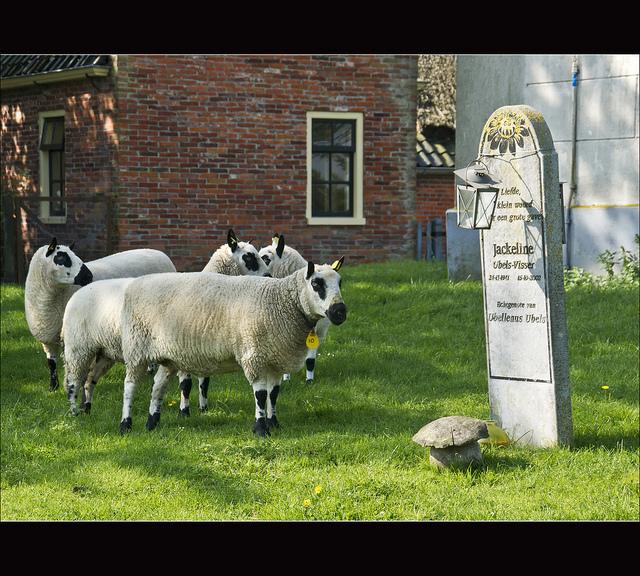How many animals are there?
Be succinct. 4. What kind of animal are these?
Keep it brief. Sheep. Is there a candle visibly burning in the lantern?
Concise answer only. No. How many of the sheep are young?
Quick response, please. 0. Are there trees visible?
Answer briefly. No. Are the animals tagged?
Short answer required. Yes. 